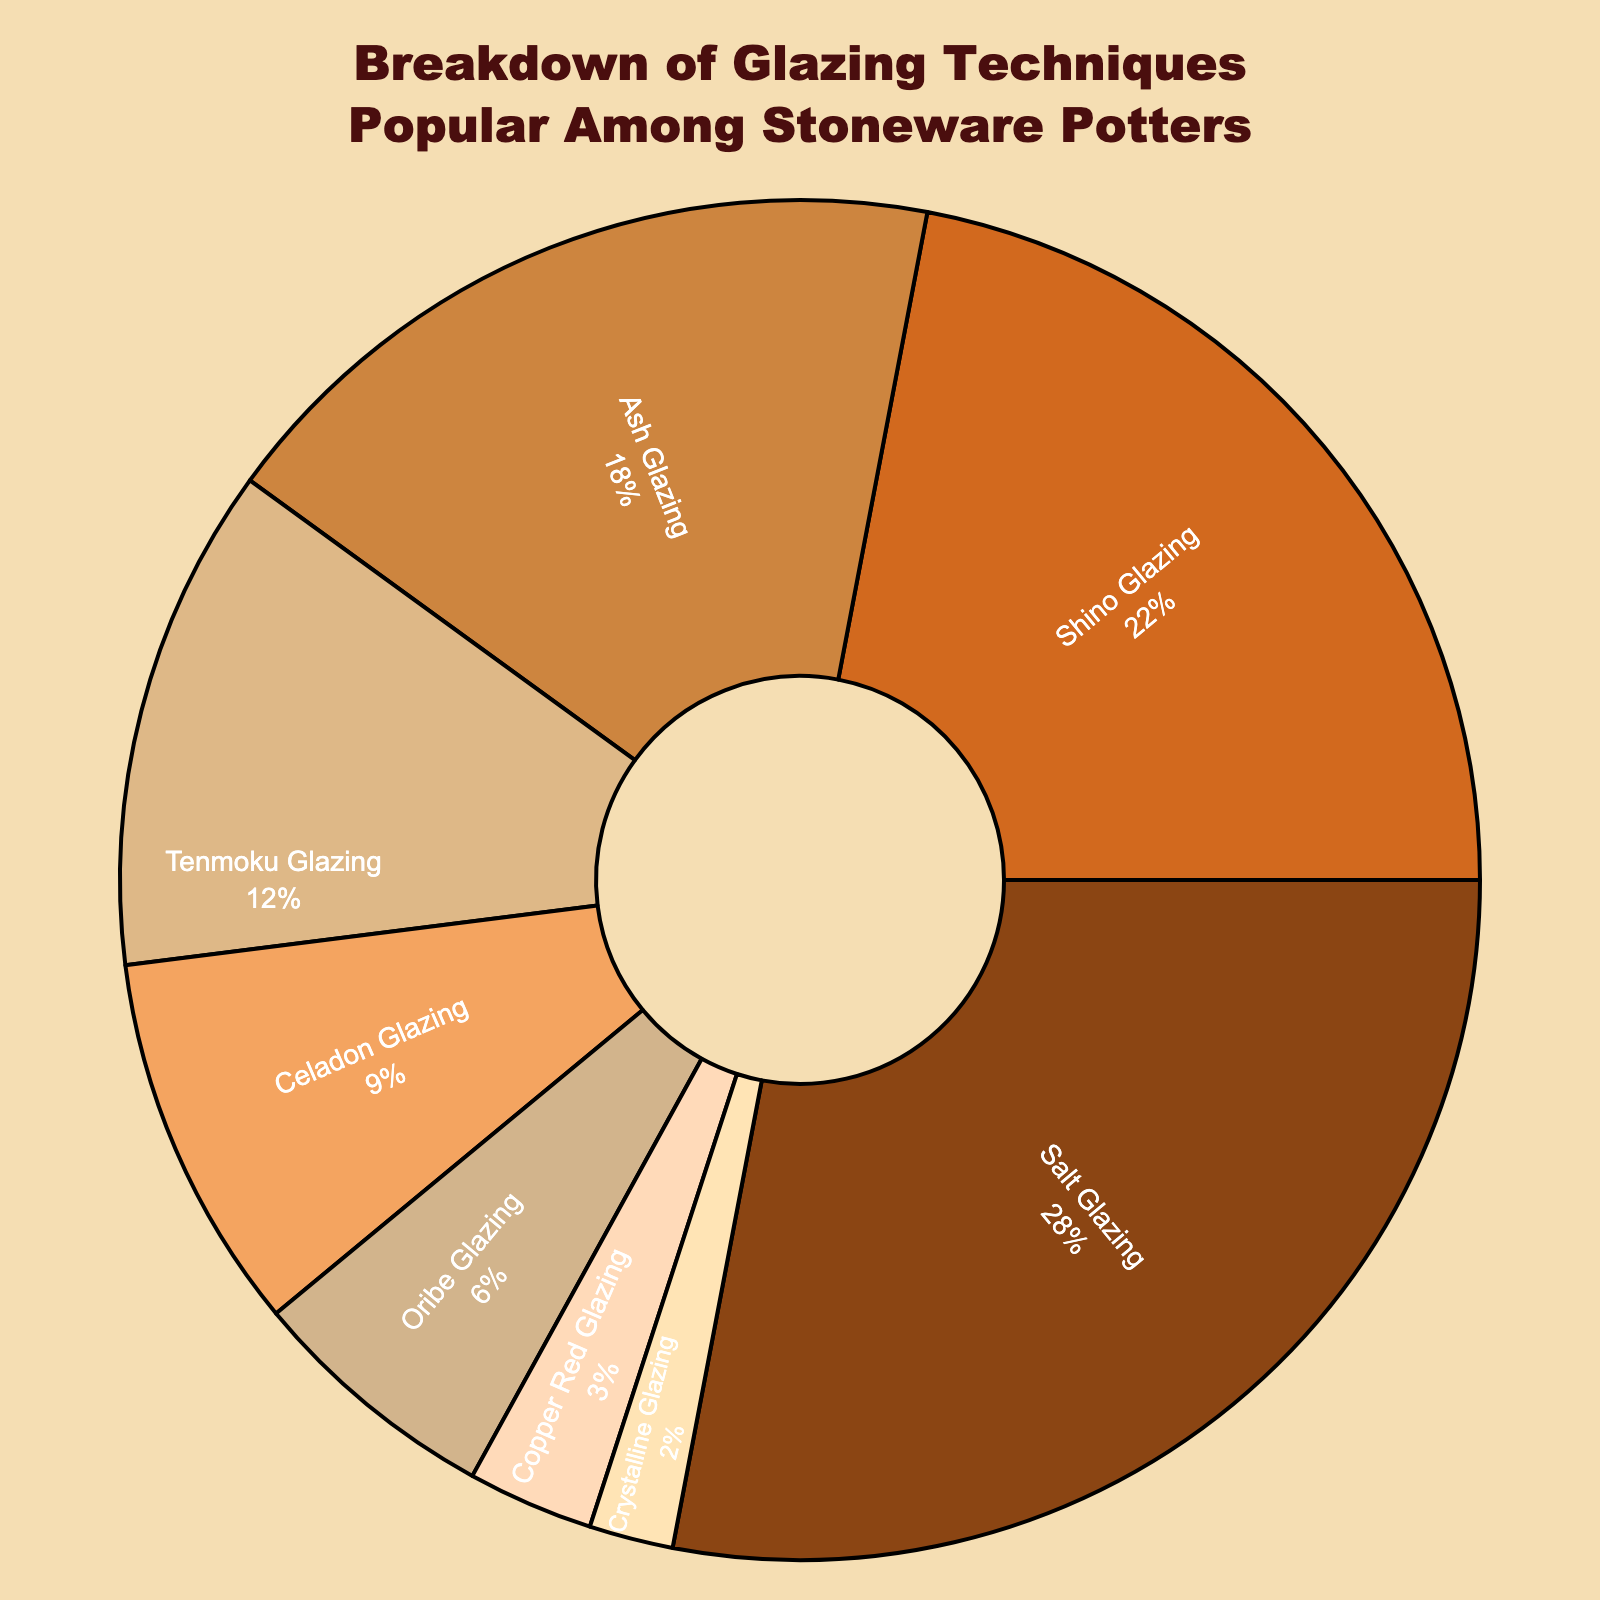What percentage of stoneware potters use Shino Glazing? Shino Glazing represents 22% as indicated by the pie chart.
Answer: 22% Which glazing technique is the least popular among stoneware potters? The pie chart shows that Crystalline Glazing is the least popular with 2%.
Answer: Crystalline Glazing How much more popular is Salt Glazing compared to Celadon Glazing? Salt Glazing is 28% and Celadon Glazing is 9%. The difference is 28% - 9% = 19%.
Answer: 19% Which two glazing techniques combined represent a higher percentage than Salt Glazing? Shino Glazing (22%) and Ash Glazing (18%) together make 22% + 18% = 40%, which is higher than Salt Glazing's 28%.
Answer: Shino Glazing and Ash Glazing Are there more potters using Ash Glazing or Tenmoku Glazing? The chart shows 18% use Ash Glazing and 12% use Tenmoku Glazing, so more potters use Ash Glazing.
Answer: Ash Glazing What is the total percentage of potters using either Oribe or Copper Red Glazing? Oribe Glazing is 6%, and Copper Red Glazing is 3%, adding up to 6% + 3% = 9%.
Answer: 9% Which glazing technique has a larger representation: Tenmoku Glazing or Celadon Glazing? Tenmoku Glazing has 12%, whereas Celadon Glazing has 9%.
Answer: Tenmoku Glazing What is the combined percentage of the four least popular glazing techniques? The four least popular techniques are Tenmoku (12%), Celadon (9%), Oribe (6%), and Copper Red (3%), totaling 12% + 9% + 6% + 3% = 30%.
Answer: 30% What is the difference in popularity between the most popular and least popular glazing techniques? Salt Glazing is the most popular at 28%, and Crystalline Glazing is the least popular at 2%. The difference is 28% - 2% = 26%.
Answer: 26% If 100 potters are sampled, how many would you expect to use Shino Glazing? Given the 22% from the pie chart, 0.22 * 100 = 22 potters would use Shino Glazing.
Answer: 22 